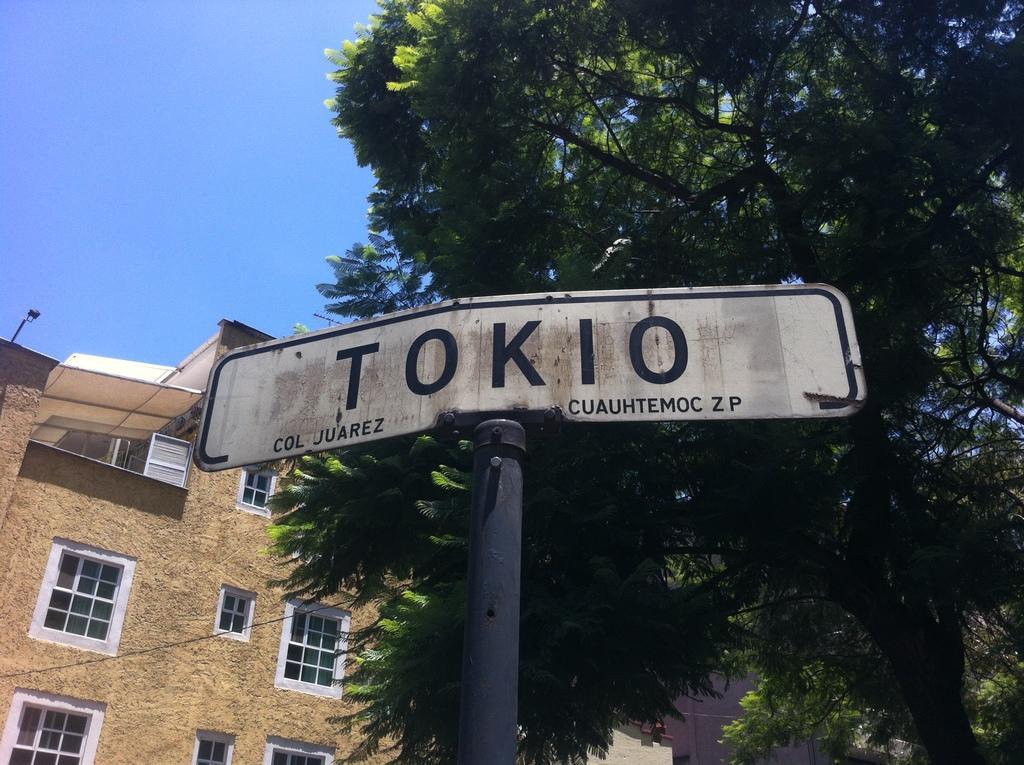Could you give a brief overview of what you see in this image? In this picture we can see a pole with a board and behind the pole there are trees, buildings and sky. 